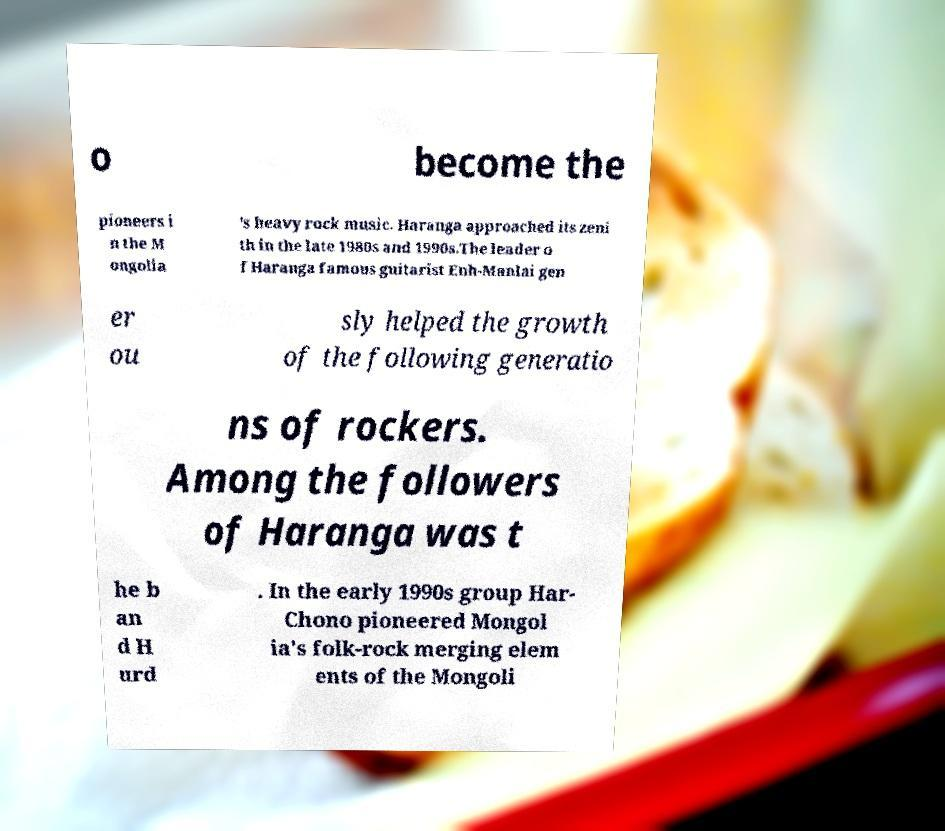I need the written content from this picture converted into text. Can you do that? o become the pioneers i n the M ongolia 's heavy rock music. Haranga approached its zeni th in the late 1980s and 1990s.The leader o f Haranga famous guitarist Enh-Manlai gen er ou sly helped the growth of the following generatio ns of rockers. Among the followers of Haranga was t he b an d H urd . In the early 1990s group Har- Chono pioneered Mongol ia's folk-rock merging elem ents of the Mongoli 